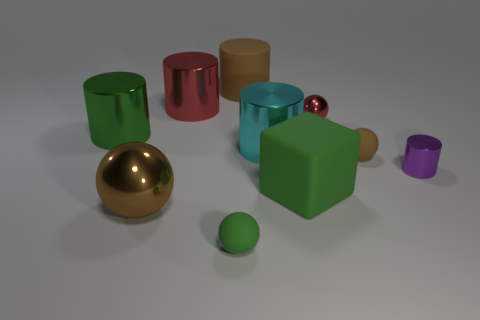Is the tiny purple thing made of the same material as the green sphere? Based on the visual properties observed in the image, the tiny purple object and the green sphere seem to have different finishes. The purple object has a matte finish, indicating it likely absorbs more light, whereas the green sphere has a glossier appearance, reflecting more light. This suggests they might be made of different materials or at least treated with different surface coatings. 